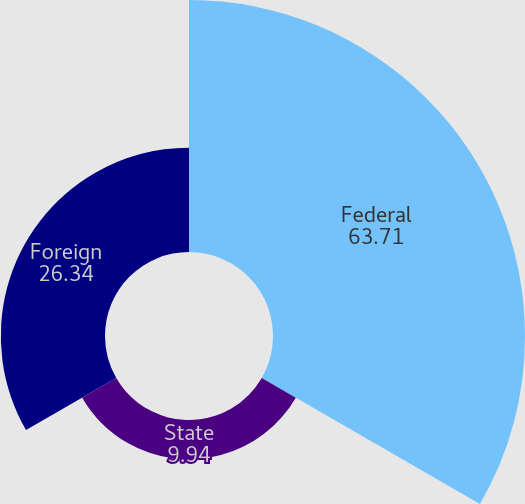Convert chart. <chart><loc_0><loc_0><loc_500><loc_500><pie_chart><fcel>Federal<fcel>State<fcel>Foreign<nl><fcel>63.71%<fcel>9.94%<fcel>26.34%<nl></chart> 